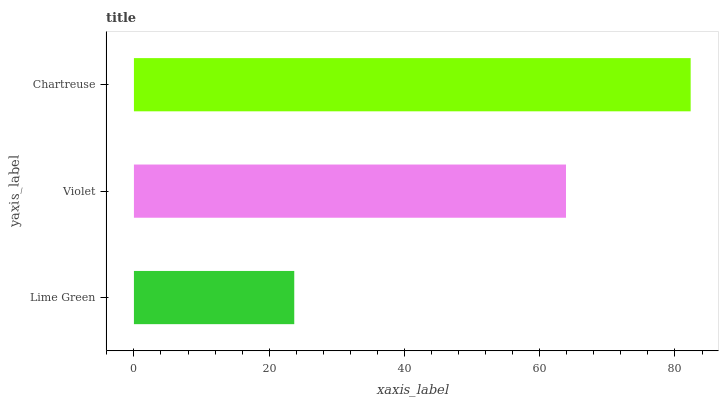Is Lime Green the minimum?
Answer yes or no. Yes. Is Chartreuse the maximum?
Answer yes or no. Yes. Is Violet the minimum?
Answer yes or no. No. Is Violet the maximum?
Answer yes or no. No. Is Violet greater than Lime Green?
Answer yes or no. Yes. Is Lime Green less than Violet?
Answer yes or no. Yes. Is Lime Green greater than Violet?
Answer yes or no. No. Is Violet less than Lime Green?
Answer yes or no. No. Is Violet the high median?
Answer yes or no. Yes. Is Violet the low median?
Answer yes or no. Yes. Is Lime Green the high median?
Answer yes or no. No. Is Lime Green the low median?
Answer yes or no. No. 